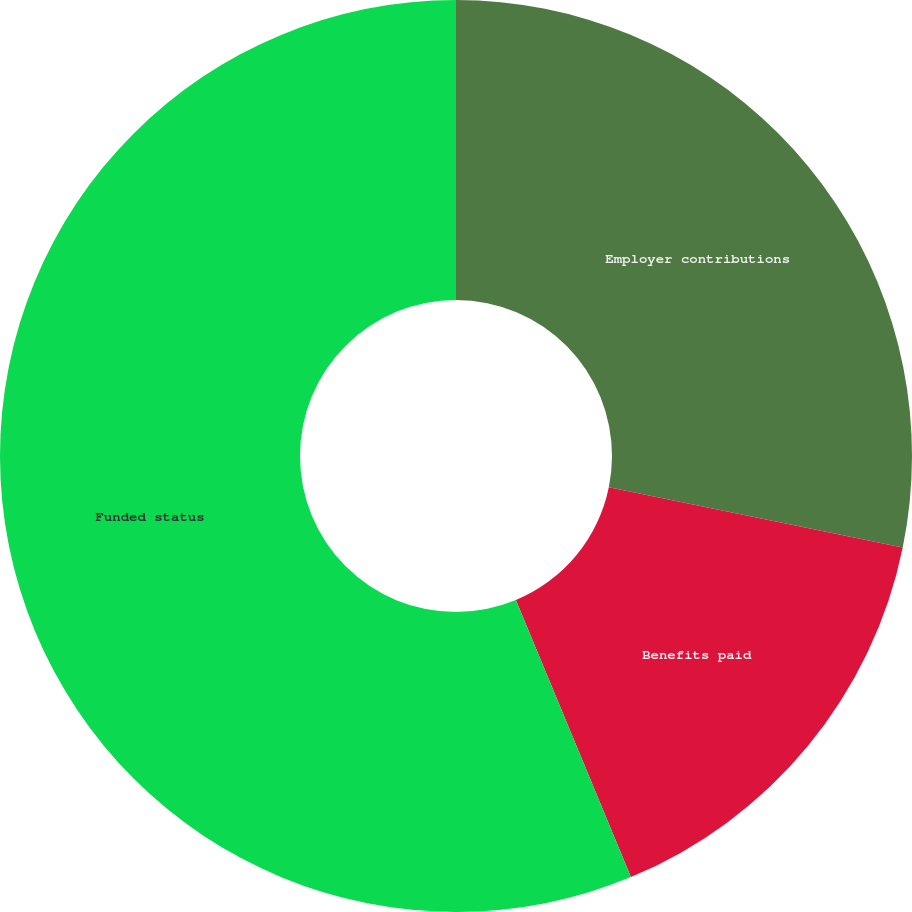Convert chart to OTSL. <chart><loc_0><loc_0><loc_500><loc_500><pie_chart><fcel>Employer contributions<fcel>Benefits paid<fcel>Funded status<nl><fcel>28.21%<fcel>15.52%<fcel>56.26%<nl></chart> 